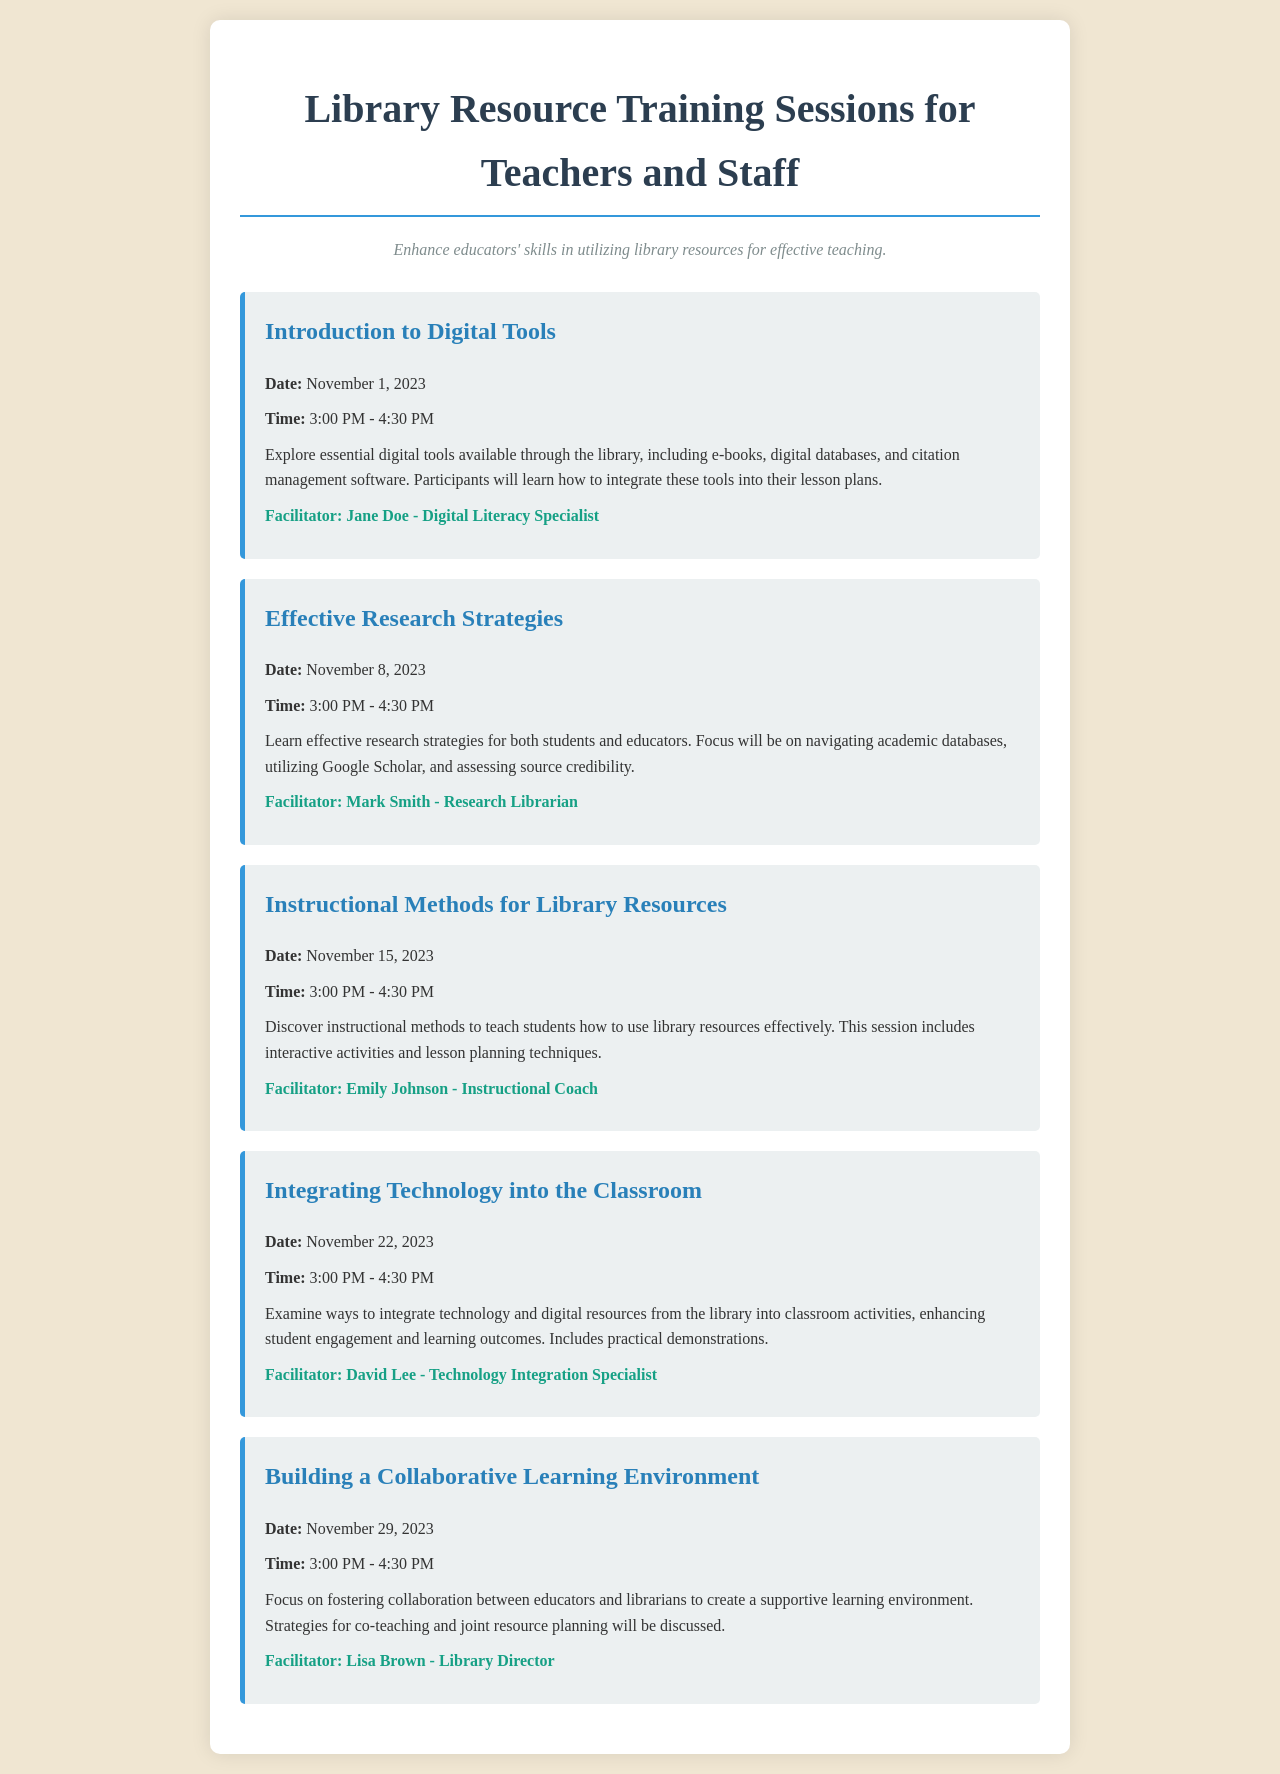What is the title of the first session? The title of the first session can be found in the document under the session details, which are organized by title, date, and time.
Answer: Introduction to Digital Tools When is the session on Effective Research Strategies? The date for the Effective Research Strategies session is specified within the session details along with the other sessions.
Answer: November 8, 2023 Who is facilitating the session on Instructional Methods for Library Resources? The facilitator for this session is listed in the details, including the name and title of the individual leading the training.
Answer: Emily Johnson - Instructional Coach What time do all sessions start? The start time for each training session is provided consistently in the document.
Answer: 3:00 PM How many sessions are scheduled in total? The total number of sessions can be counted by reviewing the distinct session entries listed in the document.
Answer: 5 Which topic covers integrating technology into classroom activities? The topic titles encompass the main themes of each session, with specific wording that indicates focus areas like technology and classroom integration.
Answer: Integrating Technology into the Classroom What is the objective of the training sessions? The objective of the sessions is stated in a separate section, summarizing the goal of enhancing educators' skills.
Answer: Enhance educators' skills in utilizing library resources for effective teaching What is the main focus of the last session? The focus of the last session can be found within the description, which elaborates on the content and activities planned for educators.
Answer: Building a Collaborative Learning Environment 